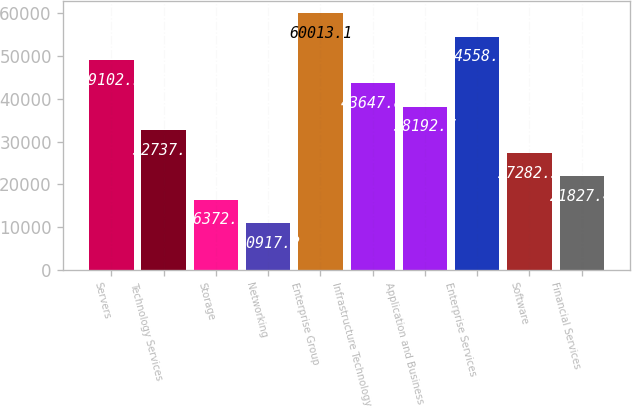<chart> <loc_0><loc_0><loc_500><loc_500><bar_chart><fcel>Servers<fcel>Technology Services<fcel>Storage<fcel>Networking<fcel>Enterprise Group<fcel>Infrastructure Technology<fcel>Application and Business<fcel>Enterprise Services<fcel>Software<fcel>Financial Services<nl><fcel>49102.9<fcel>32737.6<fcel>16372.3<fcel>10917.2<fcel>60013.1<fcel>43647.8<fcel>38192.7<fcel>54558<fcel>27282.5<fcel>21827.4<nl></chart> 